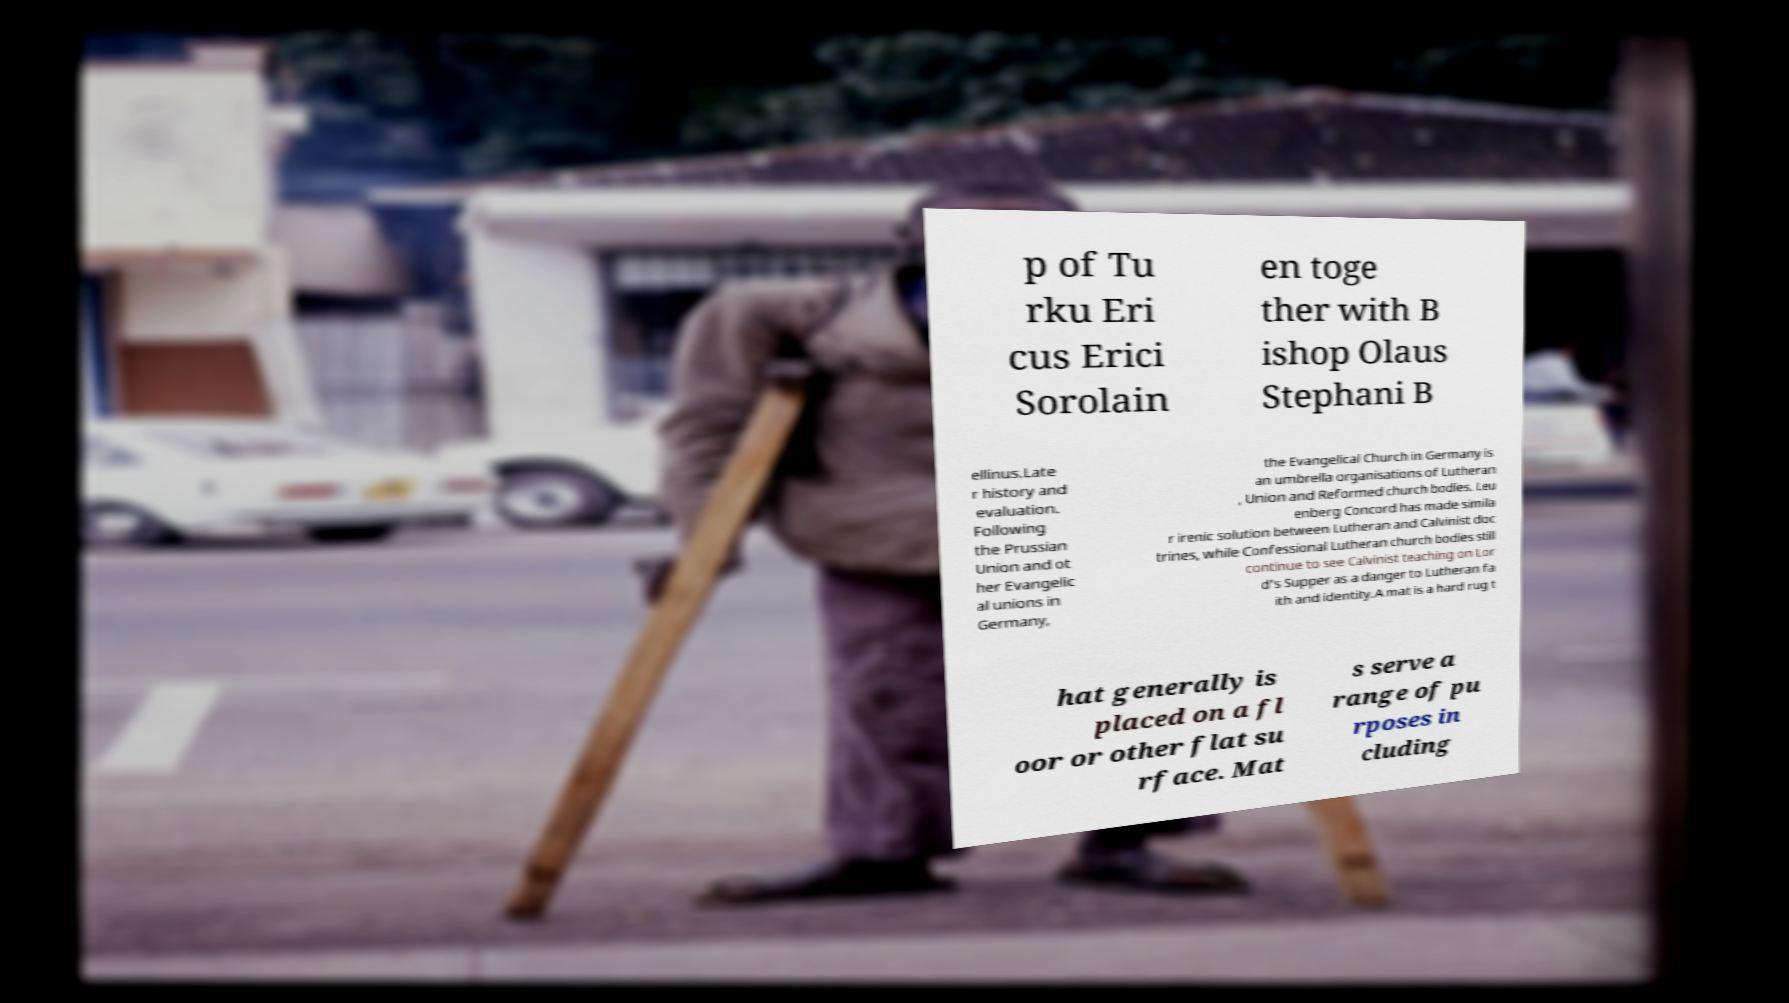Please read and relay the text visible in this image. What does it say? p of Tu rku Eri cus Erici Sorolain en toge ther with B ishop Olaus Stephani B ellinus.Late r history and evaluation. Following the Prussian Union and ot her Evangelic al unions in Germany, the Evangelical Church in Germany is an umbrella organisations of Lutheran , Union and Reformed church bodies. Leu enberg Concord has made simila r irenic solution between Lutheran and Calvinist doc trines, while Confessional Lutheran church bodies still continue to see Calvinist teaching on Lor d's Supper as a danger to Lutheran fa ith and identity.A mat is a hard rug t hat generally is placed on a fl oor or other flat su rface. Mat s serve a range of pu rposes in cluding 